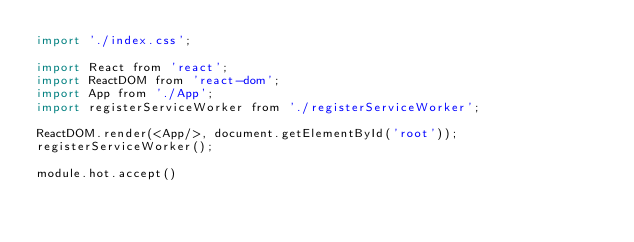<code> <loc_0><loc_0><loc_500><loc_500><_JavaScript_>import './index.css';

import React from 'react';
import ReactDOM from 'react-dom';
import App from './App';
import registerServiceWorker from './registerServiceWorker';

ReactDOM.render(<App/>, document.getElementById('root'));
registerServiceWorker();

module.hot.accept()
</code> 